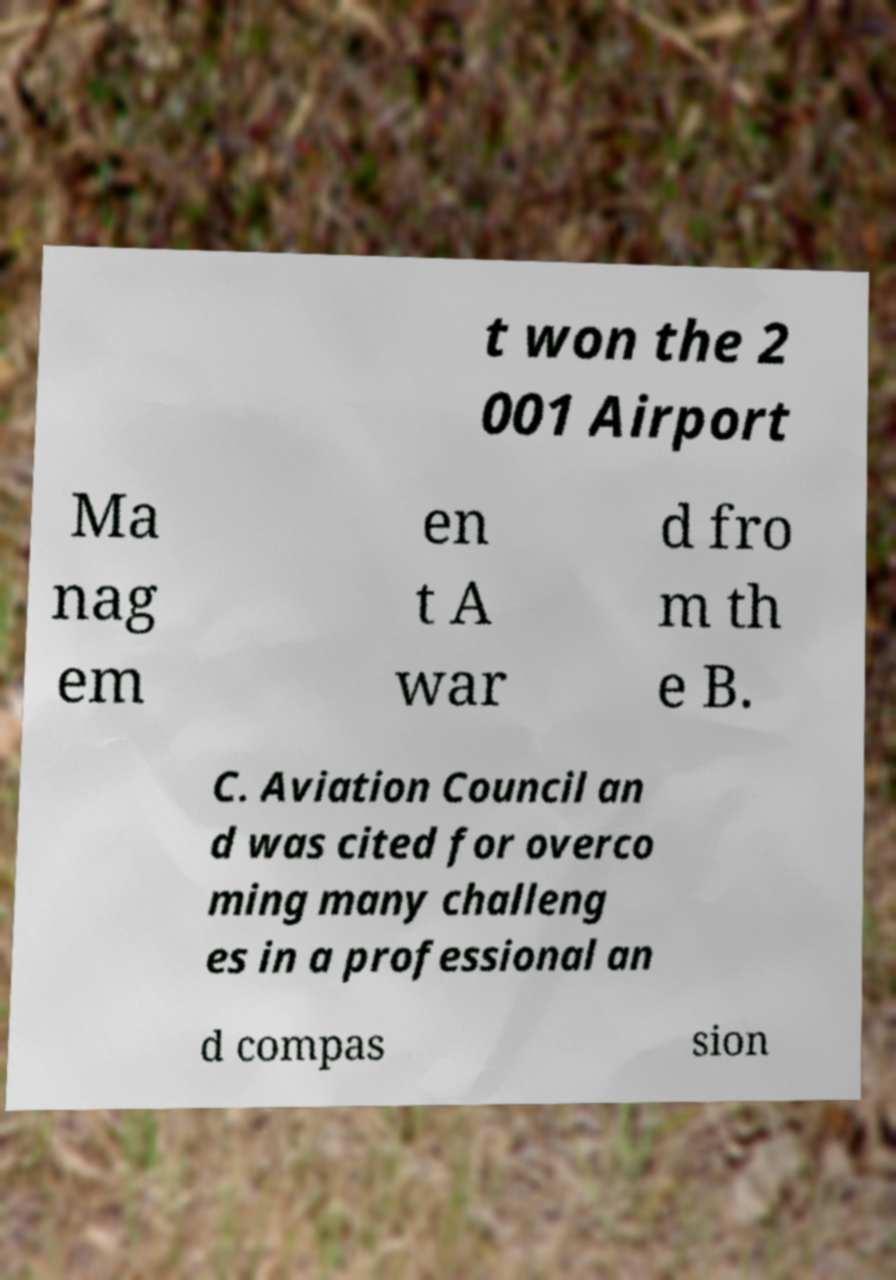Please identify and transcribe the text found in this image. t won the 2 001 Airport Ma nag em en t A war d fro m th e B. C. Aviation Council an d was cited for overco ming many challeng es in a professional an d compas sion 